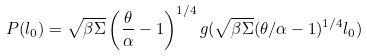<formula> <loc_0><loc_0><loc_500><loc_500>P ( l _ { 0 } ) = \sqrt { \beta \Sigma } \left ( \frac { \theta } { \alpha } - 1 \right ) ^ { 1 / 4 } g ( \sqrt { \beta \Sigma } ( \theta / \alpha - 1 ) ^ { 1 / 4 } l _ { 0 } )</formula> 